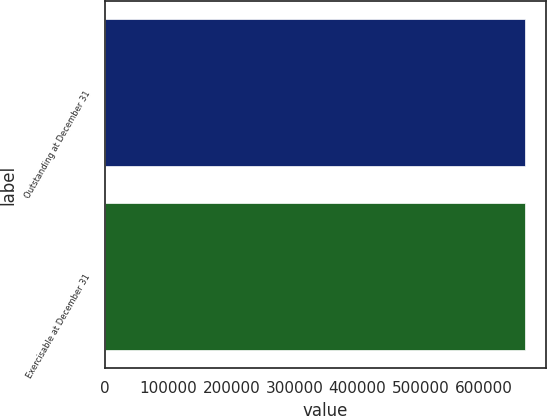Convert chart. <chart><loc_0><loc_0><loc_500><loc_500><bar_chart><fcel>Outstanding at December 31<fcel>Exercisable at December 31<nl><fcel>665412<fcel>665010<nl></chart> 